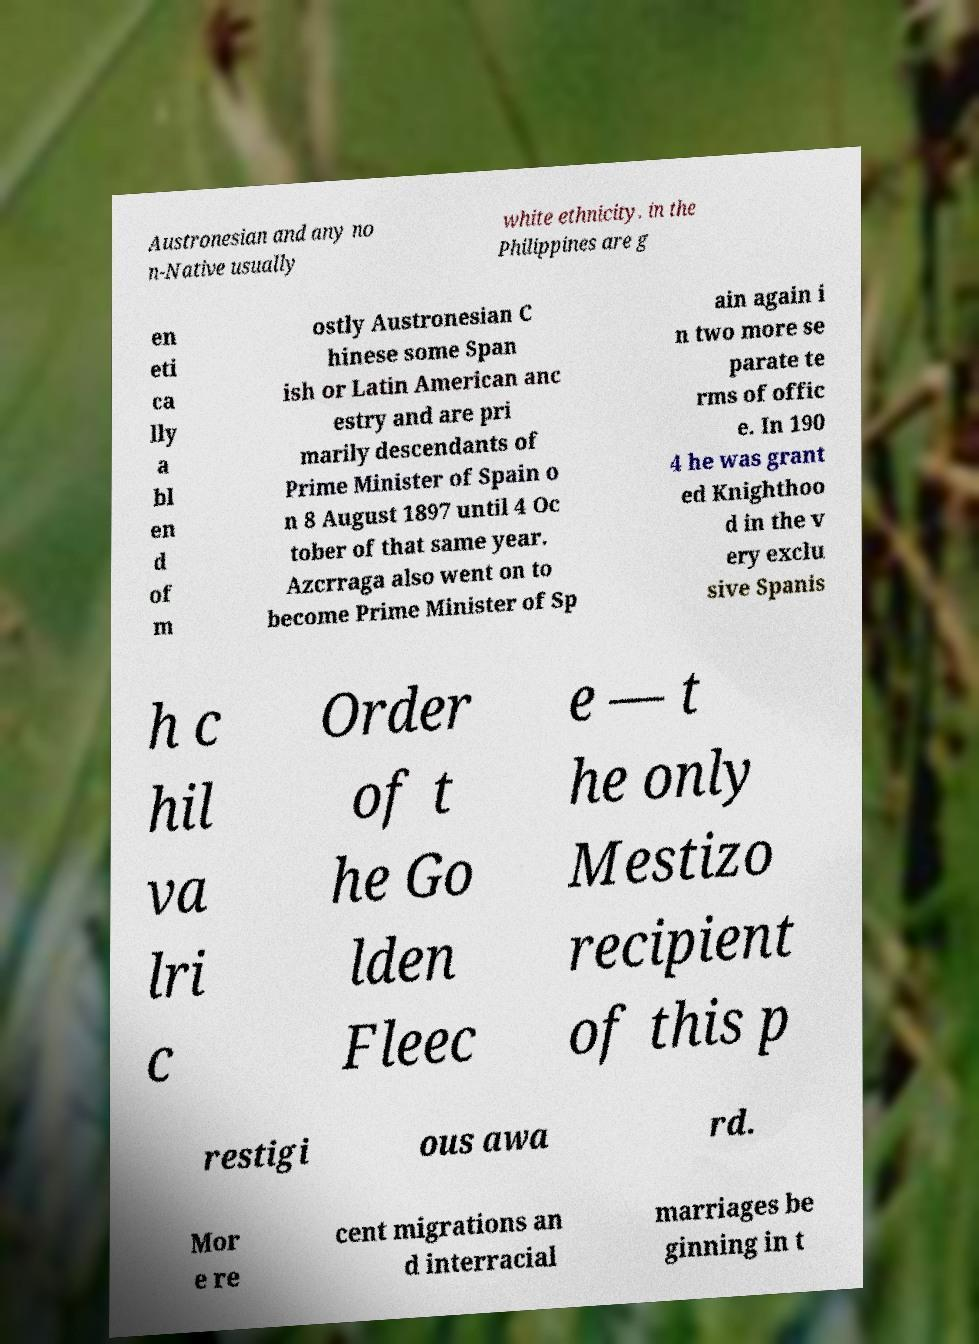Can you accurately transcribe the text from the provided image for me? Austronesian and any no n-Native usually white ethnicity. in the Philippines are g en eti ca lly a bl en d of m ostly Austronesian C hinese some Span ish or Latin American anc estry and are pri marily descendants of Prime Minister of Spain o n 8 August 1897 until 4 Oc tober of that same year. Azcrraga also went on to become Prime Minister of Sp ain again i n two more se parate te rms of offic e. In 190 4 he was grant ed Knighthoo d in the v ery exclu sive Spanis h c hil va lri c Order of t he Go lden Fleec e — t he only Mestizo recipient of this p restigi ous awa rd. Mor e re cent migrations an d interracial marriages be ginning in t 